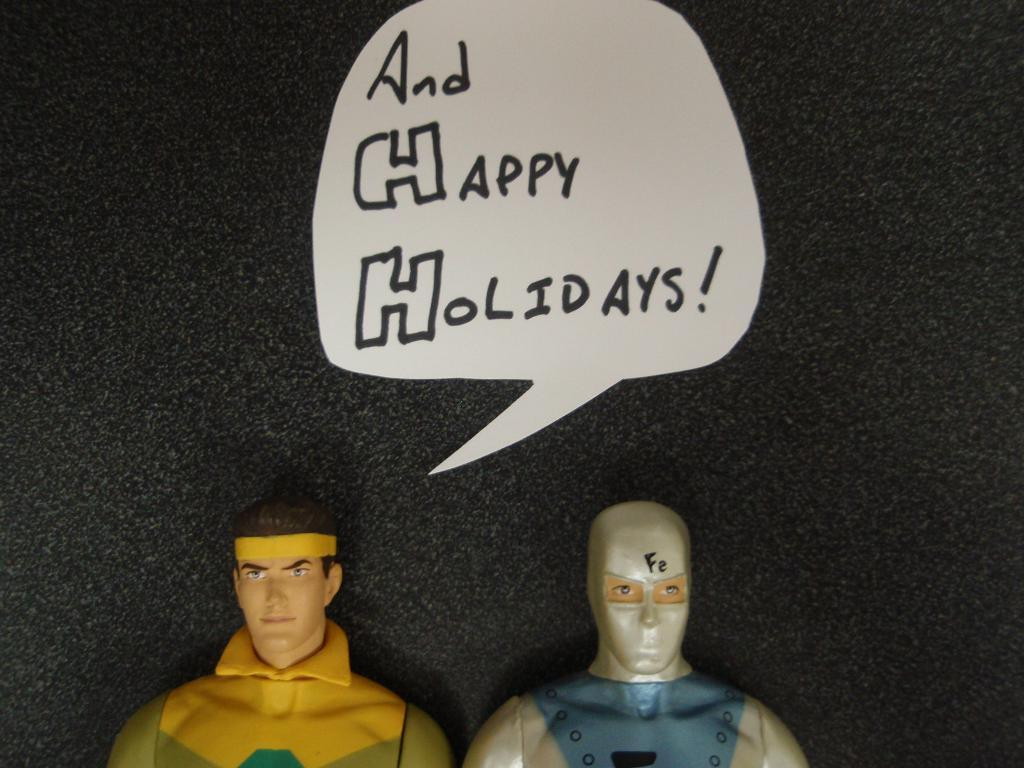What type of objects are in the image that resemble people? There are two toys in the shape of a person in the image. What colors are used in the background of the image? The background of the image is white and black. Is there any text or writing visible in the image? Yes, there is text or writing visible in the image. Can you tell me what type of law the person in the image practices? There is no person present in the image, only toys in the shape of a person. What type of street can be seen in the image? There is no street visible in the image. 